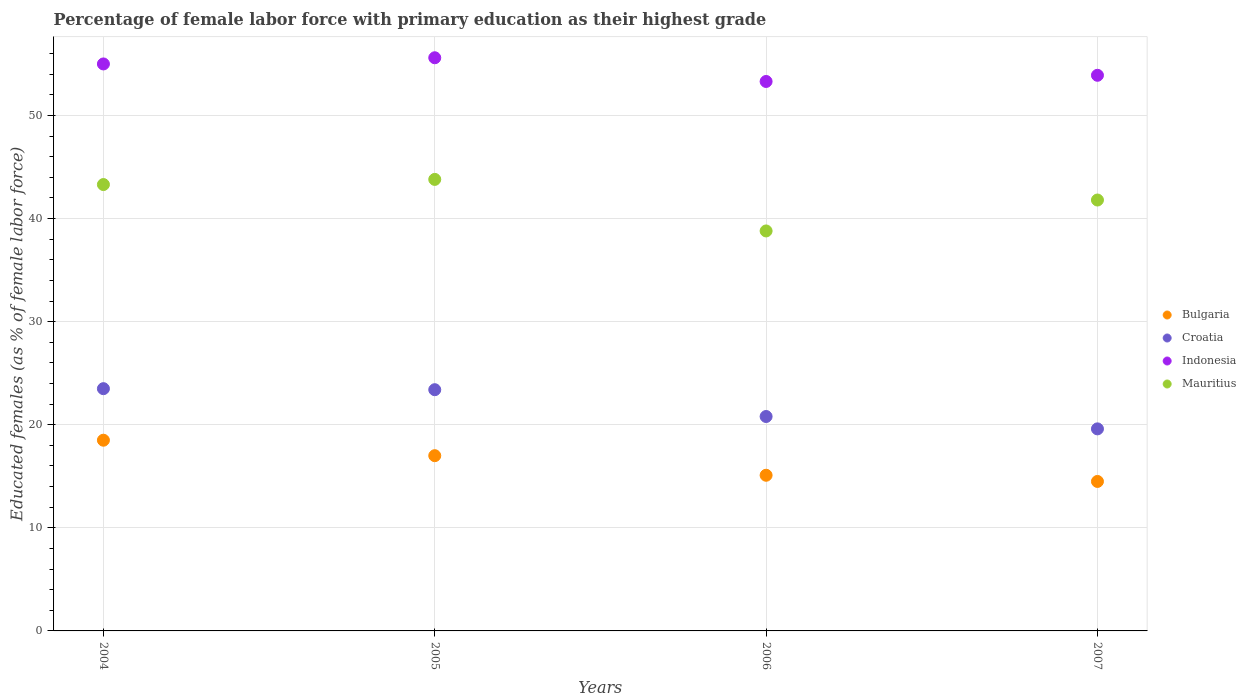Is the number of dotlines equal to the number of legend labels?
Make the answer very short. Yes. What is the percentage of female labor force with primary education in Bulgaria in 2005?
Provide a short and direct response. 17. Across all years, what is the maximum percentage of female labor force with primary education in Mauritius?
Your answer should be compact. 43.8. Across all years, what is the minimum percentage of female labor force with primary education in Bulgaria?
Offer a terse response. 14.5. What is the total percentage of female labor force with primary education in Croatia in the graph?
Make the answer very short. 87.3. What is the difference between the percentage of female labor force with primary education in Bulgaria in 2004 and that in 2006?
Offer a very short reply. 3.4. What is the difference between the percentage of female labor force with primary education in Croatia in 2004 and the percentage of female labor force with primary education in Indonesia in 2007?
Offer a terse response. -30.4. What is the average percentage of female labor force with primary education in Bulgaria per year?
Ensure brevity in your answer.  16.28. In the year 2006, what is the difference between the percentage of female labor force with primary education in Mauritius and percentage of female labor force with primary education in Bulgaria?
Keep it short and to the point. 23.7. In how many years, is the percentage of female labor force with primary education in Mauritius greater than 48 %?
Ensure brevity in your answer.  0. What is the ratio of the percentage of female labor force with primary education in Bulgaria in 2005 to that in 2006?
Your response must be concise. 1.13. Is the percentage of female labor force with primary education in Indonesia in 2004 less than that in 2006?
Your response must be concise. No. What is the difference between the highest and the second highest percentage of female labor force with primary education in Indonesia?
Give a very brief answer. 0.6. What is the difference between the highest and the lowest percentage of female labor force with primary education in Croatia?
Provide a short and direct response. 3.9. In how many years, is the percentage of female labor force with primary education in Croatia greater than the average percentage of female labor force with primary education in Croatia taken over all years?
Your response must be concise. 2. Is the percentage of female labor force with primary education in Indonesia strictly less than the percentage of female labor force with primary education in Croatia over the years?
Your answer should be very brief. No. How many dotlines are there?
Offer a very short reply. 4. What is the difference between two consecutive major ticks on the Y-axis?
Your answer should be very brief. 10. Does the graph contain any zero values?
Your answer should be very brief. No. Does the graph contain grids?
Make the answer very short. Yes. What is the title of the graph?
Your answer should be very brief. Percentage of female labor force with primary education as their highest grade. Does "Kazakhstan" appear as one of the legend labels in the graph?
Keep it short and to the point. No. What is the label or title of the Y-axis?
Give a very brief answer. Educated females (as % of female labor force). What is the Educated females (as % of female labor force) in Indonesia in 2004?
Your answer should be compact. 55. What is the Educated females (as % of female labor force) in Mauritius in 2004?
Offer a terse response. 43.3. What is the Educated females (as % of female labor force) of Bulgaria in 2005?
Give a very brief answer. 17. What is the Educated females (as % of female labor force) of Croatia in 2005?
Give a very brief answer. 23.4. What is the Educated females (as % of female labor force) of Indonesia in 2005?
Your answer should be very brief. 55.6. What is the Educated females (as % of female labor force) of Mauritius in 2005?
Give a very brief answer. 43.8. What is the Educated females (as % of female labor force) in Bulgaria in 2006?
Keep it short and to the point. 15.1. What is the Educated females (as % of female labor force) of Croatia in 2006?
Your answer should be compact. 20.8. What is the Educated females (as % of female labor force) in Indonesia in 2006?
Offer a very short reply. 53.3. What is the Educated females (as % of female labor force) in Mauritius in 2006?
Your answer should be compact. 38.8. What is the Educated females (as % of female labor force) of Croatia in 2007?
Your answer should be compact. 19.6. What is the Educated females (as % of female labor force) of Indonesia in 2007?
Keep it short and to the point. 53.9. What is the Educated females (as % of female labor force) of Mauritius in 2007?
Provide a succinct answer. 41.8. Across all years, what is the maximum Educated females (as % of female labor force) in Bulgaria?
Keep it short and to the point. 18.5. Across all years, what is the maximum Educated females (as % of female labor force) in Indonesia?
Offer a terse response. 55.6. Across all years, what is the maximum Educated females (as % of female labor force) in Mauritius?
Offer a very short reply. 43.8. Across all years, what is the minimum Educated females (as % of female labor force) in Bulgaria?
Ensure brevity in your answer.  14.5. Across all years, what is the minimum Educated females (as % of female labor force) of Croatia?
Ensure brevity in your answer.  19.6. Across all years, what is the minimum Educated females (as % of female labor force) of Indonesia?
Make the answer very short. 53.3. Across all years, what is the minimum Educated females (as % of female labor force) in Mauritius?
Your answer should be compact. 38.8. What is the total Educated females (as % of female labor force) in Bulgaria in the graph?
Keep it short and to the point. 65.1. What is the total Educated females (as % of female labor force) of Croatia in the graph?
Give a very brief answer. 87.3. What is the total Educated females (as % of female labor force) of Indonesia in the graph?
Your answer should be very brief. 217.8. What is the total Educated females (as % of female labor force) of Mauritius in the graph?
Make the answer very short. 167.7. What is the difference between the Educated females (as % of female labor force) in Bulgaria in 2004 and that in 2005?
Keep it short and to the point. 1.5. What is the difference between the Educated females (as % of female labor force) in Croatia in 2004 and that in 2005?
Offer a terse response. 0.1. What is the difference between the Educated females (as % of female labor force) of Indonesia in 2004 and that in 2005?
Provide a succinct answer. -0.6. What is the difference between the Educated females (as % of female labor force) in Bulgaria in 2004 and that in 2006?
Keep it short and to the point. 3.4. What is the difference between the Educated females (as % of female labor force) of Indonesia in 2004 and that in 2006?
Your answer should be compact. 1.7. What is the difference between the Educated females (as % of female labor force) of Mauritius in 2004 and that in 2006?
Make the answer very short. 4.5. What is the difference between the Educated females (as % of female labor force) of Indonesia in 2004 and that in 2007?
Ensure brevity in your answer.  1.1. What is the difference between the Educated females (as % of female labor force) of Mauritius in 2004 and that in 2007?
Provide a short and direct response. 1.5. What is the difference between the Educated females (as % of female labor force) in Bulgaria in 2005 and that in 2006?
Offer a very short reply. 1.9. What is the difference between the Educated females (as % of female labor force) of Indonesia in 2005 and that in 2006?
Make the answer very short. 2.3. What is the difference between the Educated females (as % of female labor force) in Indonesia in 2005 and that in 2007?
Make the answer very short. 1.7. What is the difference between the Educated females (as % of female labor force) in Mauritius in 2005 and that in 2007?
Keep it short and to the point. 2. What is the difference between the Educated females (as % of female labor force) of Bulgaria in 2006 and that in 2007?
Your answer should be very brief. 0.6. What is the difference between the Educated females (as % of female labor force) in Croatia in 2006 and that in 2007?
Offer a very short reply. 1.2. What is the difference between the Educated females (as % of female labor force) of Mauritius in 2006 and that in 2007?
Offer a terse response. -3. What is the difference between the Educated females (as % of female labor force) of Bulgaria in 2004 and the Educated females (as % of female labor force) of Indonesia in 2005?
Keep it short and to the point. -37.1. What is the difference between the Educated females (as % of female labor force) in Bulgaria in 2004 and the Educated females (as % of female labor force) in Mauritius in 2005?
Offer a terse response. -25.3. What is the difference between the Educated females (as % of female labor force) in Croatia in 2004 and the Educated females (as % of female labor force) in Indonesia in 2005?
Ensure brevity in your answer.  -32.1. What is the difference between the Educated females (as % of female labor force) in Croatia in 2004 and the Educated females (as % of female labor force) in Mauritius in 2005?
Your answer should be compact. -20.3. What is the difference between the Educated females (as % of female labor force) of Bulgaria in 2004 and the Educated females (as % of female labor force) of Croatia in 2006?
Your answer should be very brief. -2.3. What is the difference between the Educated females (as % of female labor force) in Bulgaria in 2004 and the Educated females (as % of female labor force) in Indonesia in 2006?
Give a very brief answer. -34.8. What is the difference between the Educated females (as % of female labor force) in Bulgaria in 2004 and the Educated females (as % of female labor force) in Mauritius in 2006?
Give a very brief answer. -20.3. What is the difference between the Educated females (as % of female labor force) of Croatia in 2004 and the Educated females (as % of female labor force) of Indonesia in 2006?
Your response must be concise. -29.8. What is the difference between the Educated females (as % of female labor force) in Croatia in 2004 and the Educated females (as % of female labor force) in Mauritius in 2006?
Offer a terse response. -15.3. What is the difference between the Educated females (as % of female labor force) of Bulgaria in 2004 and the Educated females (as % of female labor force) of Croatia in 2007?
Make the answer very short. -1.1. What is the difference between the Educated females (as % of female labor force) of Bulgaria in 2004 and the Educated females (as % of female labor force) of Indonesia in 2007?
Make the answer very short. -35.4. What is the difference between the Educated females (as % of female labor force) of Bulgaria in 2004 and the Educated females (as % of female labor force) of Mauritius in 2007?
Provide a short and direct response. -23.3. What is the difference between the Educated females (as % of female labor force) in Croatia in 2004 and the Educated females (as % of female labor force) in Indonesia in 2007?
Offer a very short reply. -30.4. What is the difference between the Educated females (as % of female labor force) of Croatia in 2004 and the Educated females (as % of female labor force) of Mauritius in 2007?
Give a very brief answer. -18.3. What is the difference between the Educated females (as % of female labor force) of Indonesia in 2004 and the Educated females (as % of female labor force) of Mauritius in 2007?
Give a very brief answer. 13.2. What is the difference between the Educated females (as % of female labor force) of Bulgaria in 2005 and the Educated females (as % of female labor force) of Indonesia in 2006?
Offer a very short reply. -36.3. What is the difference between the Educated females (as % of female labor force) in Bulgaria in 2005 and the Educated females (as % of female labor force) in Mauritius in 2006?
Make the answer very short. -21.8. What is the difference between the Educated females (as % of female labor force) of Croatia in 2005 and the Educated females (as % of female labor force) of Indonesia in 2006?
Offer a very short reply. -29.9. What is the difference between the Educated females (as % of female labor force) in Croatia in 2005 and the Educated females (as % of female labor force) in Mauritius in 2006?
Your answer should be very brief. -15.4. What is the difference between the Educated females (as % of female labor force) of Bulgaria in 2005 and the Educated females (as % of female labor force) of Croatia in 2007?
Give a very brief answer. -2.6. What is the difference between the Educated females (as % of female labor force) in Bulgaria in 2005 and the Educated females (as % of female labor force) in Indonesia in 2007?
Your response must be concise. -36.9. What is the difference between the Educated females (as % of female labor force) in Bulgaria in 2005 and the Educated females (as % of female labor force) in Mauritius in 2007?
Your response must be concise. -24.8. What is the difference between the Educated females (as % of female labor force) of Croatia in 2005 and the Educated females (as % of female labor force) of Indonesia in 2007?
Your answer should be compact. -30.5. What is the difference between the Educated females (as % of female labor force) in Croatia in 2005 and the Educated females (as % of female labor force) in Mauritius in 2007?
Ensure brevity in your answer.  -18.4. What is the difference between the Educated females (as % of female labor force) in Bulgaria in 2006 and the Educated females (as % of female labor force) in Croatia in 2007?
Provide a short and direct response. -4.5. What is the difference between the Educated females (as % of female labor force) in Bulgaria in 2006 and the Educated females (as % of female labor force) in Indonesia in 2007?
Keep it short and to the point. -38.8. What is the difference between the Educated females (as % of female labor force) of Bulgaria in 2006 and the Educated females (as % of female labor force) of Mauritius in 2007?
Offer a terse response. -26.7. What is the difference between the Educated females (as % of female labor force) of Croatia in 2006 and the Educated females (as % of female labor force) of Indonesia in 2007?
Offer a terse response. -33.1. What is the average Educated females (as % of female labor force) in Bulgaria per year?
Provide a short and direct response. 16.27. What is the average Educated females (as % of female labor force) of Croatia per year?
Your answer should be very brief. 21.82. What is the average Educated females (as % of female labor force) in Indonesia per year?
Offer a very short reply. 54.45. What is the average Educated females (as % of female labor force) in Mauritius per year?
Offer a terse response. 41.92. In the year 2004, what is the difference between the Educated females (as % of female labor force) of Bulgaria and Educated females (as % of female labor force) of Indonesia?
Your response must be concise. -36.5. In the year 2004, what is the difference between the Educated females (as % of female labor force) of Bulgaria and Educated females (as % of female labor force) of Mauritius?
Your answer should be compact. -24.8. In the year 2004, what is the difference between the Educated females (as % of female labor force) of Croatia and Educated females (as % of female labor force) of Indonesia?
Keep it short and to the point. -31.5. In the year 2004, what is the difference between the Educated females (as % of female labor force) of Croatia and Educated females (as % of female labor force) of Mauritius?
Your answer should be compact. -19.8. In the year 2004, what is the difference between the Educated females (as % of female labor force) of Indonesia and Educated females (as % of female labor force) of Mauritius?
Your answer should be compact. 11.7. In the year 2005, what is the difference between the Educated females (as % of female labor force) in Bulgaria and Educated females (as % of female labor force) in Indonesia?
Your answer should be compact. -38.6. In the year 2005, what is the difference between the Educated females (as % of female labor force) of Bulgaria and Educated females (as % of female labor force) of Mauritius?
Your response must be concise. -26.8. In the year 2005, what is the difference between the Educated females (as % of female labor force) in Croatia and Educated females (as % of female labor force) in Indonesia?
Provide a succinct answer. -32.2. In the year 2005, what is the difference between the Educated females (as % of female labor force) in Croatia and Educated females (as % of female labor force) in Mauritius?
Your answer should be very brief. -20.4. In the year 2005, what is the difference between the Educated females (as % of female labor force) in Indonesia and Educated females (as % of female labor force) in Mauritius?
Your answer should be compact. 11.8. In the year 2006, what is the difference between the Educated females (as % of female labor force) of Bulgaria and Educated females (as % of female labor force) of Indonesia?
Provide a succinct answer. -38.2. In the year 2006, what is the difference between the Educated females (as % of female labor force) of Bulgaria and Educated females (as % of female labor force) of Mauritius?
Provide a succinct answer. -23.7. In the year 2006, what is the difference between the Educated females (as % of female labor force) of Croatia and Educated females (as % of female labor force) of Indonesia?
Offer a very short reply. -32.5. In the year 2006, what is the difference between the Educated females (as % of female labor force) of Croatia and Educated females (as % of female labor force) of Mauritius?
Keep it short and to the point. -18. In the year 2006, what is the difference between the Educated females (as % of female labor force) of Indonesia and Educated females (as % of female labor force) of Mauritius?
Your response must be concise. 14.5. In the year 2007, what is the difference between the Educated females (as % of female labor force) of Bulgaria and Educated females (as % of female labor force) of Indonesia?
Provide a succinct answer. -39.4. In the year 2007, what is the difference between the Educated females (as % of female labor force) of Bulgaria and Educated females (as % of female labor force) of Mauritius?
Offer a terse response. -27.3. In the year 2007, what is the difference between the Educated females (as % of female labor force) of Croatia and Educated females (as % of female labor force) of Indonesia?
Provide a succinct answer. -34.3. In the year 2007, what is the difference between the Educated females (as % of female labor force) in Croatia and Educated females (as % of female labor force) in Mauritius?
Make the answer very short. -22.2. In the year 2007, what is the difference between the Educated females (as % of female labor force) of Indonesia and Educated females (as % of female labor force) of Mauritius?
Ensure brevity in your answer.  12.1. What is the ratio of the Educated females (as % of female labor force) in Bulgaria in 2004 to that in 2005?
Offer a very short reply. 1.09. What is the ratio of the Educated females (as % of female labor force) in Croatia in 2004 to that in 2005?
Keep it short and to the point. 1. What is the ratio of the Educated females (as % of female labor force) of Indonesia in 2004 to that in 2005?
Keep it short and to the point. 0.99. What is the ratio of the Educated females (as % of female labor force) of Mauritius in 2004 to that in 2005?
Give a very brief answer. 0.99. What is the ratio of the Educated females (as % of female labor force) of Bulgaria in 2004 to that in 2006?
Your answer should be compact. 1.23. What is the ratio of the Educated females (as % of female labor force) in Croatia in 2004 to that in 2006?
Your response must be concise. 1.13. What is the ratio of the Educated females (as % of female labor force) of Indonesia in 2004 to that in 2006?
Provide a succinct answer. 1.03. What is the ratio of the Educated females (as % of female labor force) in Mauritius in 2004 to that in 2006?
Provide a short and direct response. 1.12. What is the ratio of the Educated females (as % of female labor force) in Bulgaria in 2004 to that in 2007?
Your response must be concise. 1.28. What is the ratio of the Educated females (as % of female labor force) of Croatia in 2004 to that in 2007?
Offer a very short reply. 1.2. What is the ratio of the Educated females (as % of female labor force) in Indonesia in 2004 to that in 2007?
Provide a short and direct response. 1.02. What is the ratio of the Educated females (as % of female labor force) of Mauritius in 2004 to that in 2007?
Offer a terse response. 1.04. What is the ratio of the Educated females (as % of female labor force) in Bulgaria in 2005 to that in 2006?
Provide a succinct answer. 1.13. What is the ratio of the Educated females (as % of female labor force) in Croatia in 2005 to that in 2006?
Make the answer very short. 1.12. What is the ratio of the Educated females (as % of female labor force) of Indonesia in 2005 to that in 2006?
Provide a short and direct response. 1.04. What is the ratio of the Educated females (as % of female labor force) of Mauritius in 2005 to that in 2006?
Your response must be concise. 1.13. What is the ratio of the Educated females (as % of female labor force) in Bulgaria in 2005 to that in 2007?
Your answer should be compact. 1.17. What is the ratio of the Educated females (as % of female labor force) in Croatia in 2005 to that in 2007?
Your response must be concise. 1.19. What is the ratio of the Educated females (as % of female labor force) of Indonesia in 2005 to that in 2007?
Make the answer very short. 1.03. What is the ratio of the Educated females (as % of female labor force) in Mauritius in 2005 to that in 2007?
Keep it short and to the point. 1.05. What is the ratio of the Educated females (as % of female labor force) in Bulgaria in 2006 to that in 2007?
Make the answer very short. 1.04. What is the ratio of the Educated females (as % of female labor force) of Croatia in 2006 to that in 2007?
Keep it short and to the point. 1.06. What is the ratio of the Educated females (as % of female labor force) of Indonesia in 2006 to that in 2007?
Give a very brief answer. 0.99. What is the ratio of the Educated females (as % of female labor force) in Mauritius in 2006 to that in 2007?
Offer a terse response. 0.93. What is the difference between the highest and the second highest Educated females (as % of female labor force) in Bulgaria?
Your response must be concise. 1.5. What is the difference between the highest and the second highest Educated females (as % of female labor force) of Indonesia?
Make the answer very short. 0.6. What is the difference between the highest and the second highest Educated females (as % of female labor force) of Mauritius?
Offer a terse response. 0.5. What is the difference between the highest and the lowest Educated females (as % of female labor force) in Bulgaria?
Provide a succinct answer. 4. What is the difference between the highest and the lowest Educated females (as % of female labor force) in Indonesia?
Your answer should be very brief. 2.3. What is the difference between the highest and the lowest Educated females (as % of female labor force) of Mauritius?
Ensure brevity in your answer.  5. 